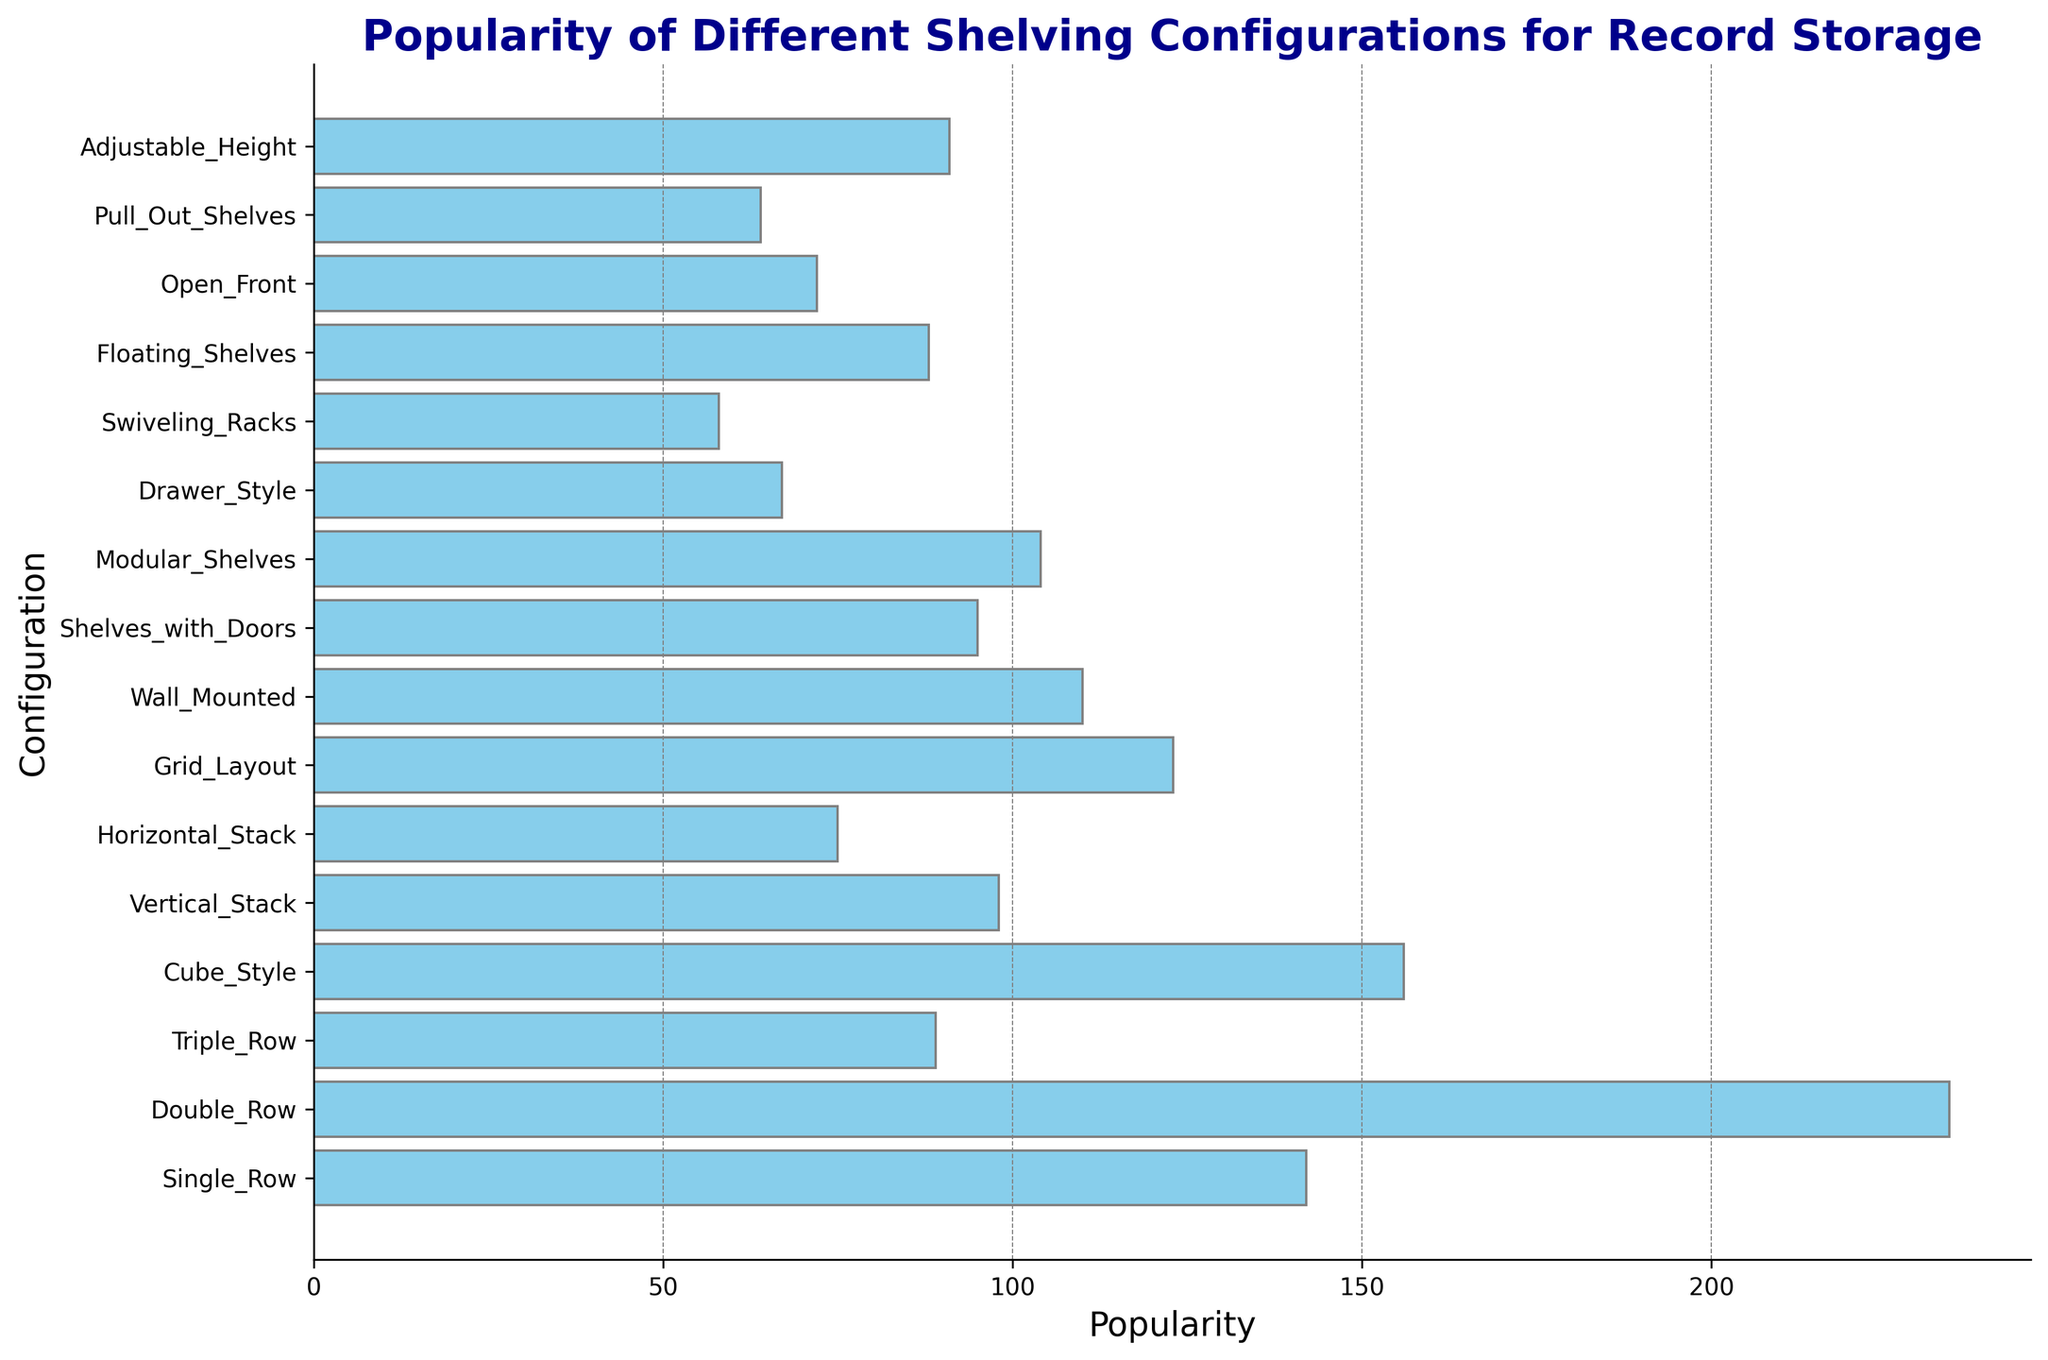Which shelving configuration is the most popular? The bar for "Double_Row" is the longest, indicating that it has the highest popularity.
Answer: Double_Row Which shelving configuration is the least popular? The bar for "Swiveling_Racks" is the shortest, indicating that it has the lowest popularity.
Answer: Swiveling_Racks What is the combined popularity of "Single_Row" and "Cube_Style" configurations? The popularity of "Single_Row" is 142 and for "Cube_Style" is 156. Summing them gives 142 + 156 = 298.
Answer: 298 How much more popular is "Double_Row" compared to "Drawer_Style"? The popularity of "Double_Row" is 234, and for "Drawer_Style" it is 67. The difference is 234 - 67 = 167.
Answer: 167 Which configuration is more popular: "Wall_Mounted" or "Floating_Shelves"? The bar for "Wall_Mounted" is longer than that of "Floating_Shelves". "Wall_Mounted" has a popularity of 110 and "Floating_Shelves" 88.
Answer: Wall_Mounted Which three configurations have similar popularity levels? "Modular_Shelves", "Adjustable_Height", and "Grid_Layout" have similar bar lengths. Their popularity values are 104, 91, and 123 respectively.
Answer: Modular_Shelves, Adjustable_Height, Grid_Layout What is the average popularity of "Vertical_Stack", "Horizontal_Stack", and "Open_Front"? The popularity values are 98, 75, and 72. The sum is 98 + 75 + 72 = 245, and the average is 245 / 3 = 81.67.
Answer: 81.67 Are there more configurations with popularity values above or below 100? Configurations above 100 are "Single_Row", "Double_Row", "Cube_Style", "Wall_Mounted", "Grid_Layout", and "Modular_Shelves" — 6 configurations. Below 100 are the remaining — 10 configurations.
Answer: Below What is the popularity difference between "Open_Front" and "Pull_Out_Shelves"? "Open_Front" has a popularity of 72, and "Pull_Out_Shelves" has 64. The difference is 72 - 64 = 8.
Answer: 8 Is the popularity of "Triple_Row" above or below the average popularity of all configurations? The sum of popularity values for all configurations is 1562. There are 16 configurations, so the average is 1562 / 16 = 97.625. "Triple_Row" has a popularity of 89 which is below the average.
Answer: Below 